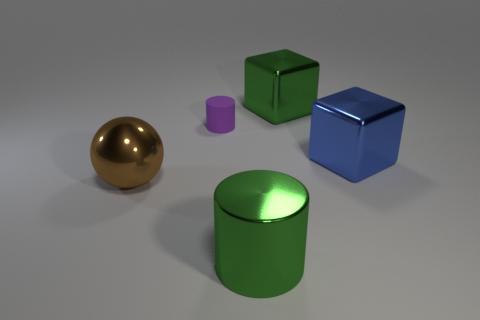Can you tell me what materials these objects could be made of based on their appearance? Based on their lustrous surfaces and the way they reflect light, these objects appear to be rendered to simulate metallic materials. The blue and green objects, due to their perfect, smooth surfaces might represent idealized metal or specially coated polymers in a real-world setting. 